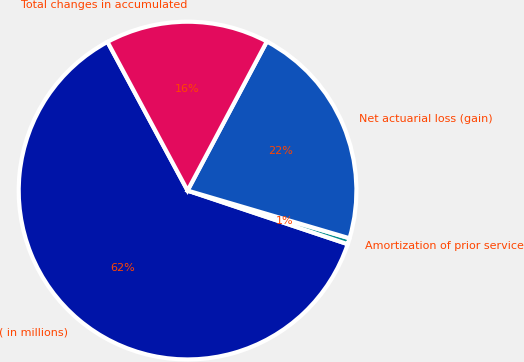<chart> <loc_0><loc_0><loc_500><loc_500><pie_chart><fcel>( in millions)<fcel>Amortization of prior service<fcel>Net actuarial loss (gain)<fcel>Total changes in accumulated<nl><fcel>62.0%<fcel>0.58%<fcel>21.78%<fcel>15.64%<nl></chart> 